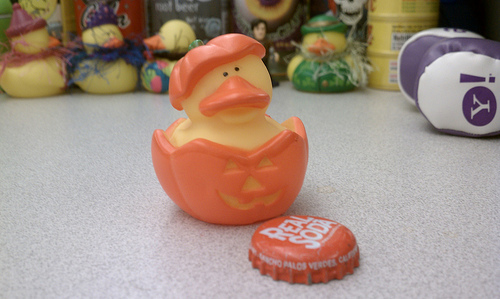<image>
Can you confirm if the pumpkin is above the floor? No. The pumpkin is not positioned above the floor. The vertical arrangement shows a different relationship. 